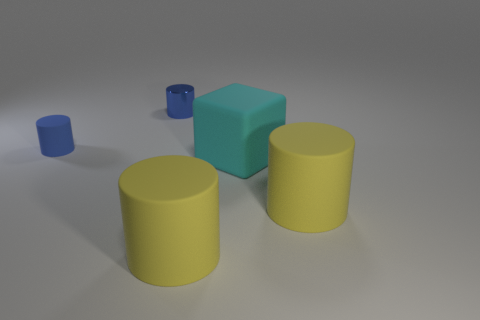Subtract all blue rubber cylinders. How many cylinders are left? 3 Subtract all cylinders. How many objects are left? 1 Subtract 1 cubes. How many cubes are left? 0 Subtract all yellow cylinders. How many cylinders are left? 2 Add 4 small things. How many small things exist? 6 Add 3 large blue metallic cubes. How many objects exist? 8 Subtract 0 blue spheres. How many objects are left? 5 Subtract all red cubes. Subtract all cyan balls. How many cubes are left? 1 Subtract all green spheres. How many green cylinders are left? 0 Subtract all small blue metallic objects. Subtract all large matte cylinders. How many objects are left? 2 